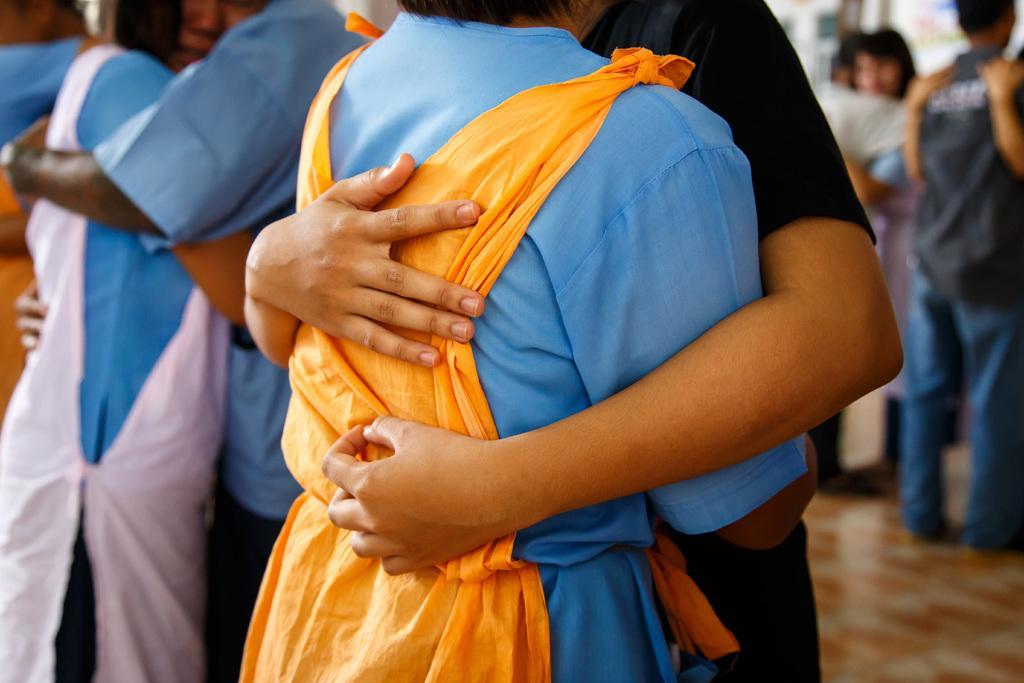Please provide a concise description of this image. In this image, we can see people hugging each other and at the bottom, there is a floor. 